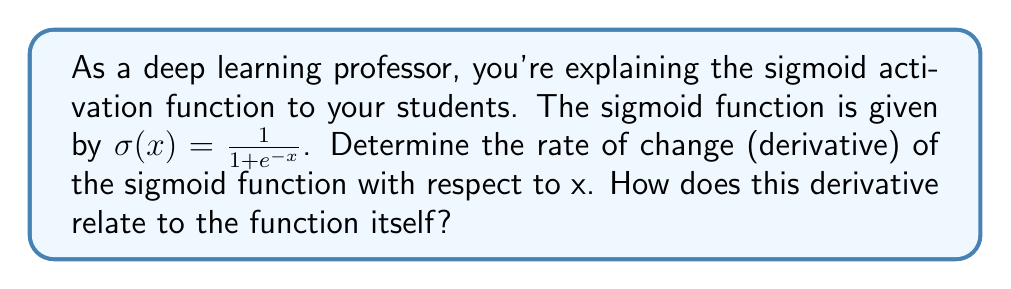Teach me how to tackle this problem. To find the rate of change of the sigmoid function, we need to calculate its derivative. Let's approach this step-by-step:

1) Start with the sigmoid function: $\sigma(x) = \frac{1}{1 + e^{-x}}$

2) To differentiate this, we can use the quotient rule: $\frac{d}{dx}[\frac{f(x)}{g(x)}] = \frac{f'(x)g(x) - f(x)g'(x)}{[g(x)]^2}$

   Here, $f(x) = 1$ and $g(x) = 1 + e^{-x}$

3) $f'(x) = 0$ (derivative of a constant)
   $g'(x) = -e^{-x}$ (using the chain rule)

4) Applying the quotient rule:

   $$\frac{d}{dx}[\sigma(x)] = \frac{0 \cdot (1 + e^{-x}) - 1 \cdot (-e^{-x})}{(1 + e^{-x})^2}$$

5) Simplifying:

   $$\frac{d}{dx}[\sigma(x)] = \frac{e^{-x}}{(1 + e^{-x})^2}$$

6) Now, let's recall that $\sigma(x) = \frac{1}{1 + e^{-x}}$. We can rewrite our derivative in terms of $\sigma(x)$:

   $$\frac{d}{dx}[\sigma(x)] = \sigma(x) \cdot \frac{e^{-x}}{1 + e^{-x}}$$

7) Note that $\frac{e^{-x}}{1 + e^{-x}} = 1 - \sigma(x)$

8) Therefore, we can express the derivative as:

   $$\frac{d}{dx}[\sigma(x)] = \sigma(x) \cdot (1 - \sigma(x))$$

This result shows that the rate of change of the sigmoid function at any point is equal to the value of the function at that point multiplied by one minus the value of the function at that point. This property makes the sigmoid function particularly useful in neural networks, as it provides a smooth, bounded output with a simple derivative that can be expressed in terms of the function itself.
Answer: The rate of change (derivative) of the sigmoid function is:

$$\frac{d}{dx}[\sigma(x)] = \sigma(x) \cdot (1 - \sigma(x))$$

This derivative relates to the function itself by being expressible entirely in terms of the original function, which is a valuable property for computational efficiency in neural networks. 